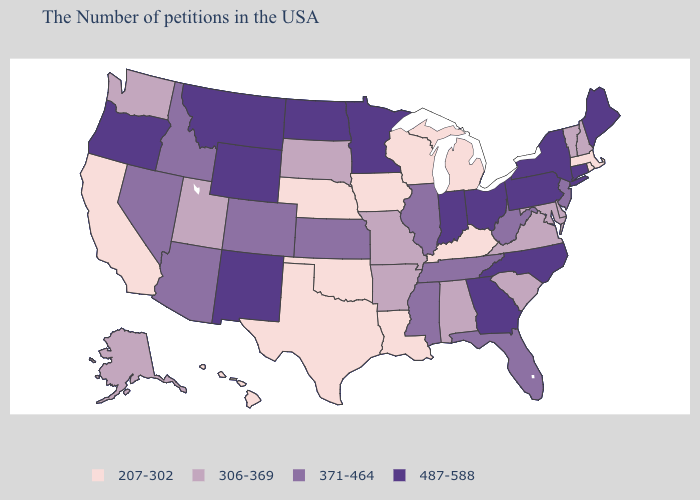Does Oklahoma have the highest value in the USA?
Answer briefly. No. Among the states that border Wisconsin , which have the lowest value?
Write a very short answer. Michigan, Iowa. Does South Carolina have the same value as Arkansas?
Quick response, please. Yes. Does New Hampshire have a lower value than Massachusetts?
Be succinct. No. What is the highest value in the MidWest ?
Quick response, please. 487-588. What is the value of Texas?
Write a very short answer. 207-302. What is the highest value in the USA?
Concise answer only. 487-588. Does the map have missing data?
Write a very short answer. No. Which states hav the highest value in the South?
Be succinct. North Carolina, Georgia. Is the legend a continuous bar?
Concise answer only. No. Which states have the highest value in the USA?
Keep it brief. Maine, Connecticut, New York, Pennsylvania, North Carolina, Ohio, Georgia, Indiana, Minnesota, North Dakota, Wyoming, New Mexico, Montana, Oregon. What is the value of Indiana?
Quick response, please. 487-588. Among the states that border Pennsylvania , which have the highest value?
Quick response, please. New York, Ohio. Does Michigan have the highest value in the MidWest?
Answer briefly. No. Which states have the lowest value in the MidWest?
Answer briefly. Michigan, Wisconsin, Iowa, Nebraska. 